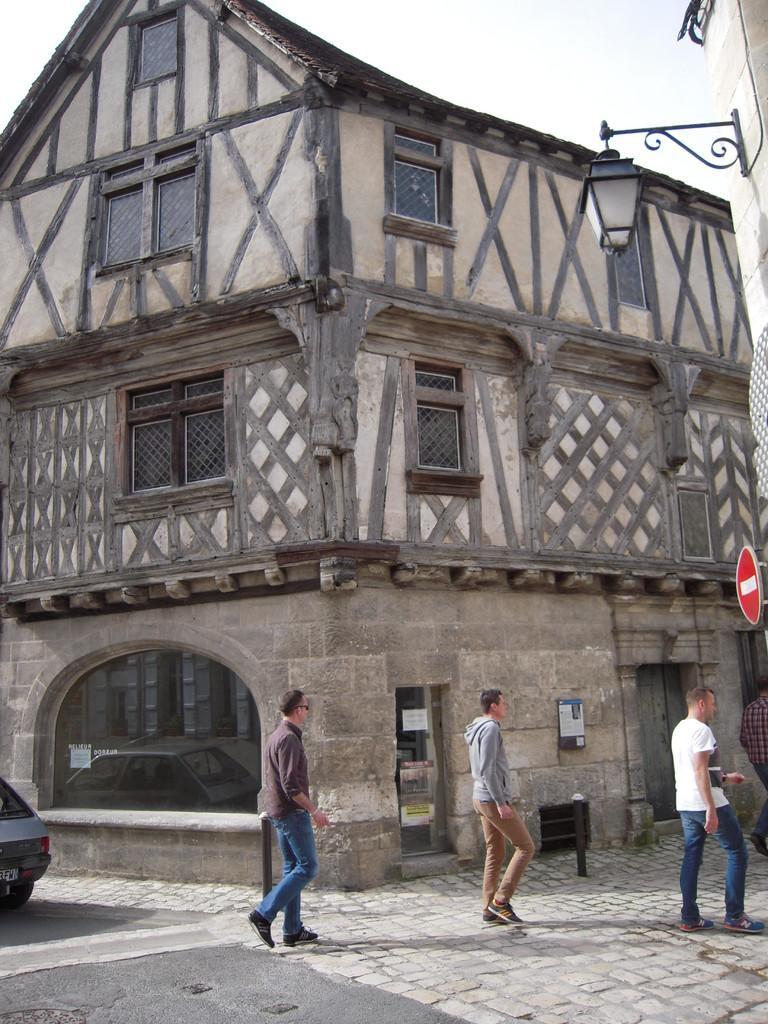Describe this image in one or two sentences. There are people walking on the road. We can see buildings. On the left side of the image we can see car. On the right side of the image we can see board and light. In the background we can see sky. 